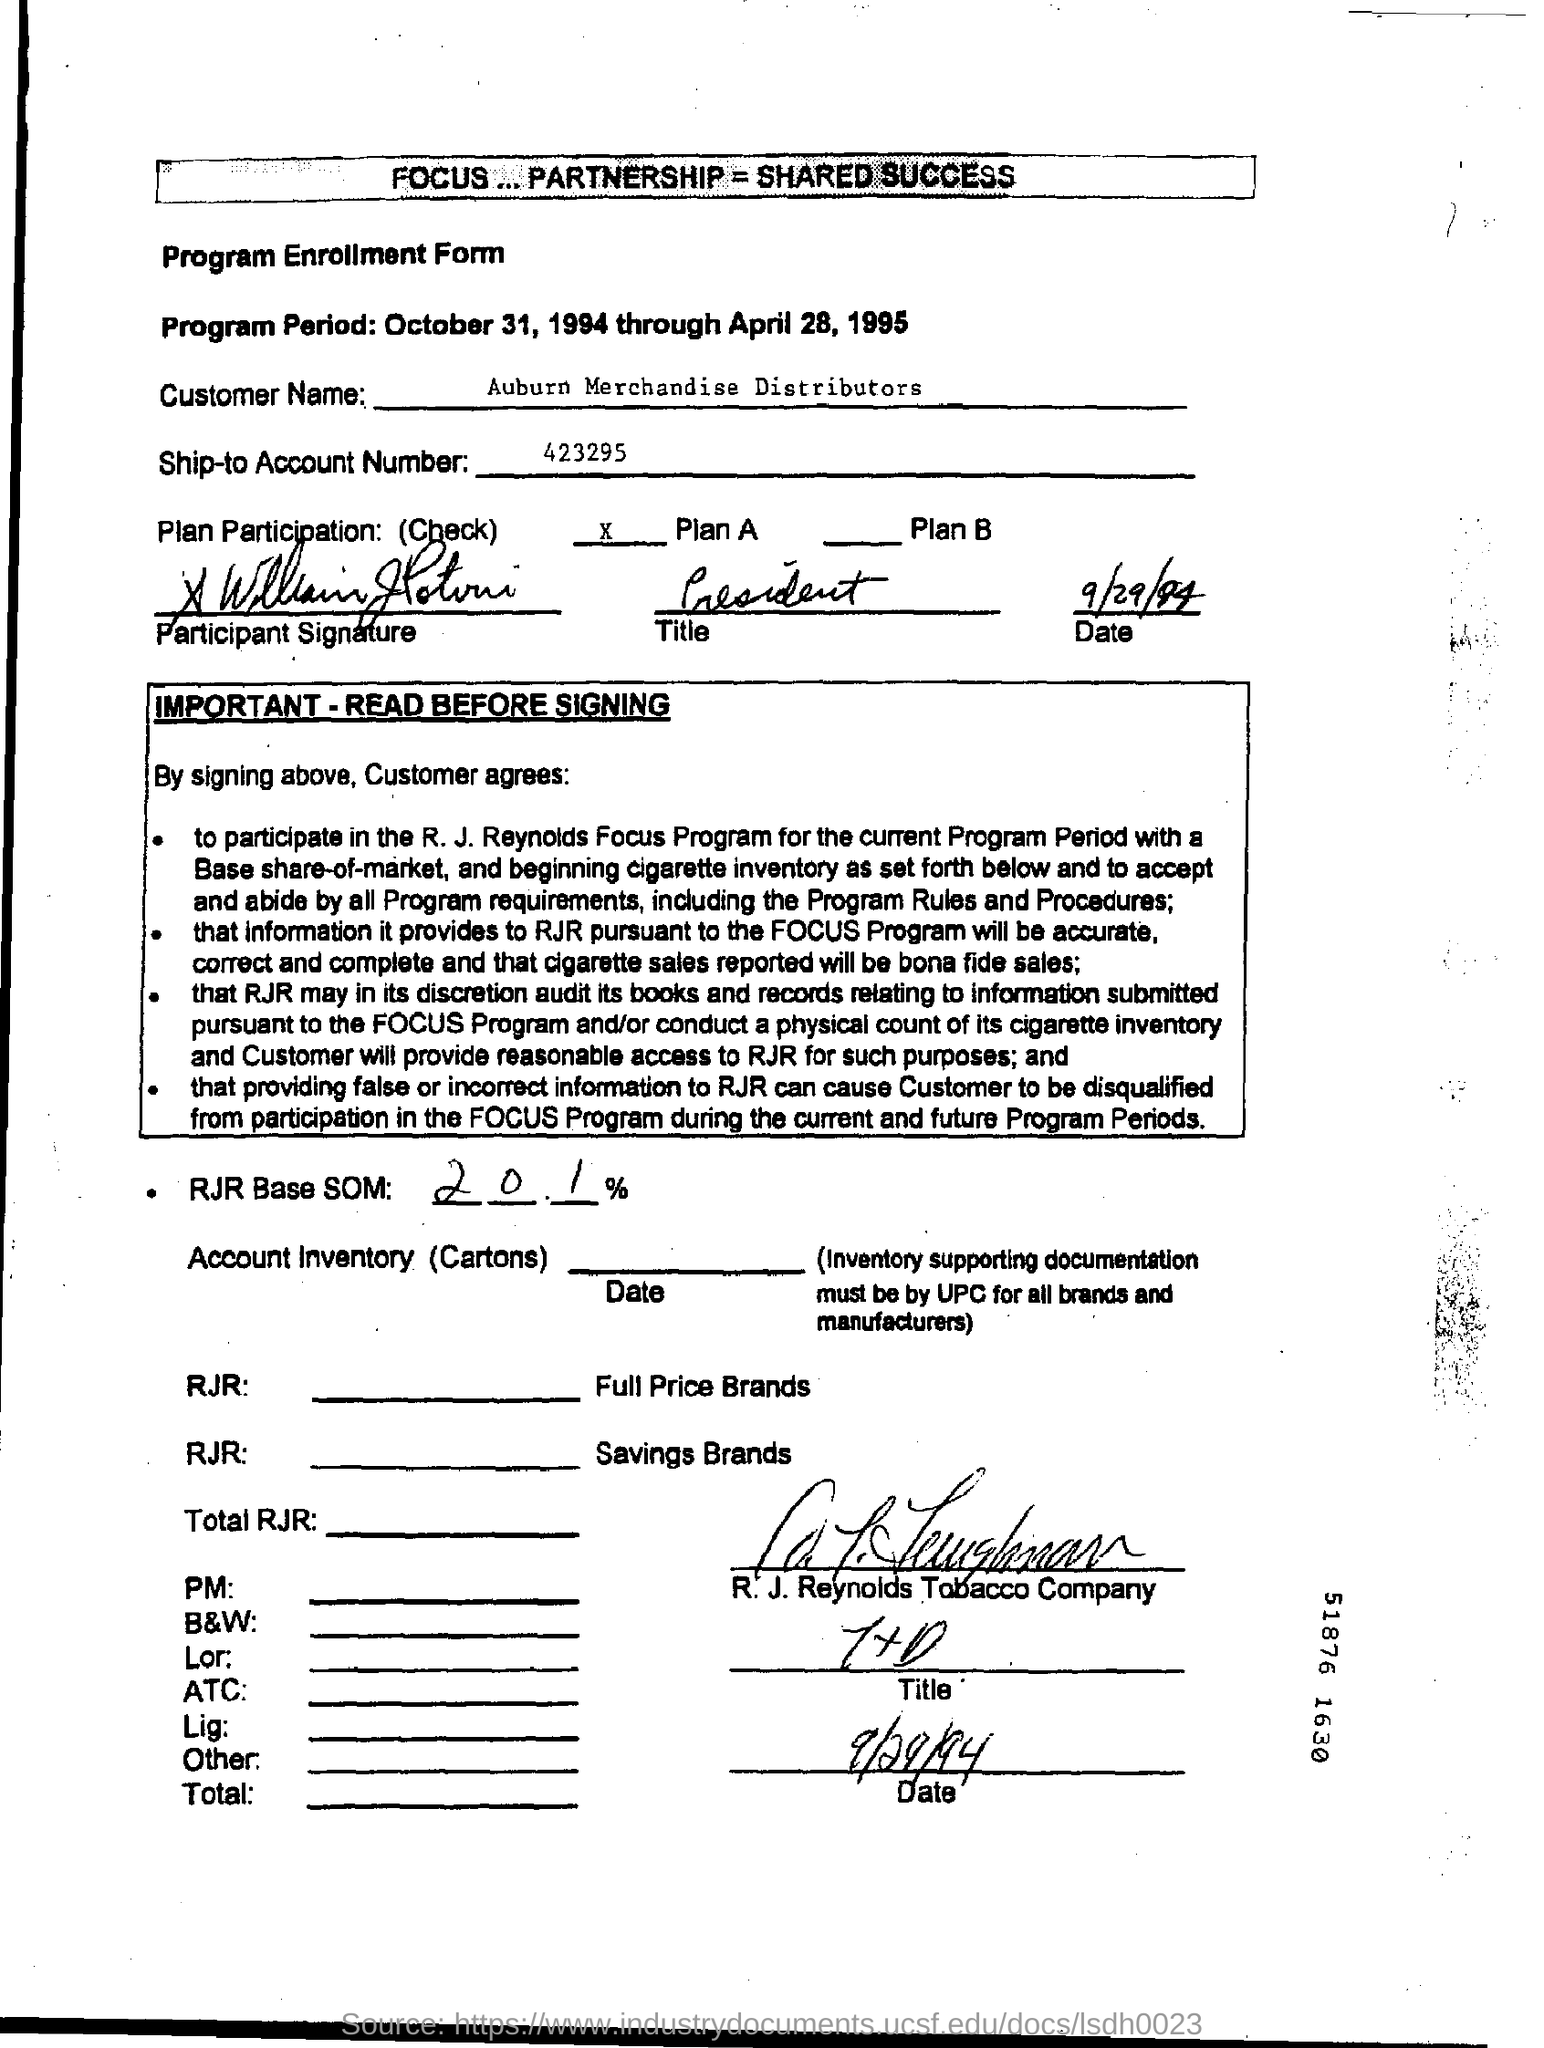List a handful of essential elements in this visual. The customer name is Auburn Merchandise Distributors. The date mentioned in the bottom of the document is September 29, 1994. The percentage of RJR Base SOM is 20.1%. The ship-to account number provided in the form is 423295... The program took place from October 31, 1994, to April 28, 1995. 